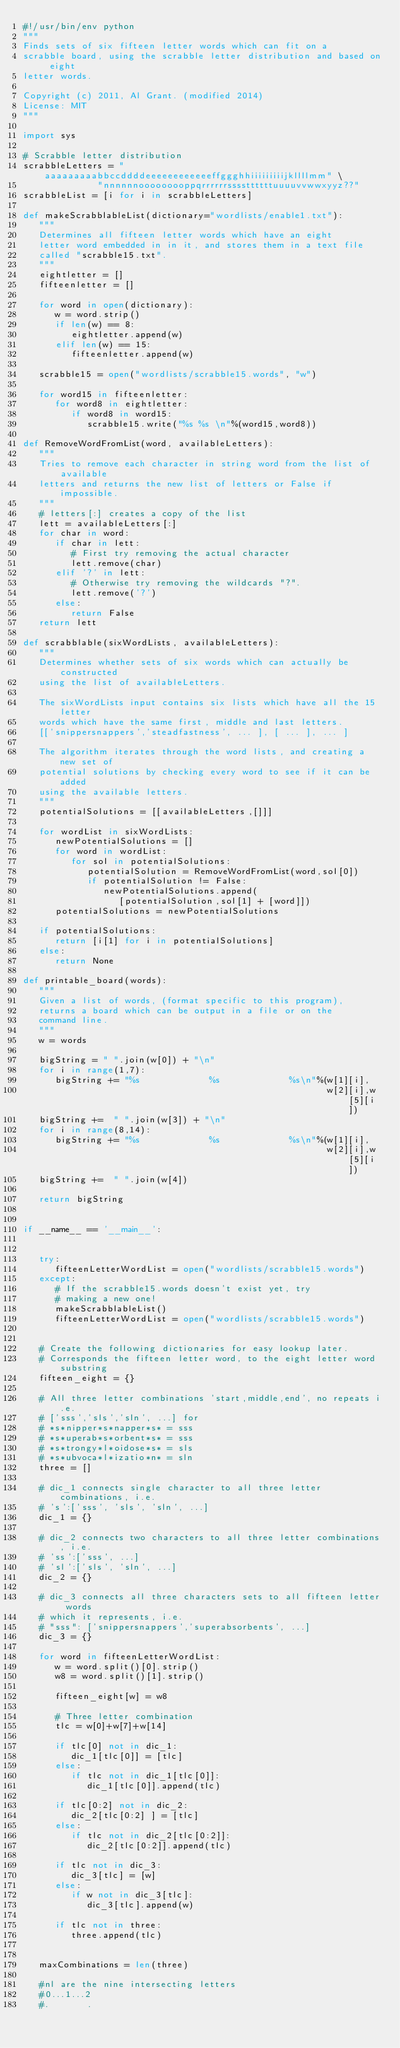Convert code to text. <code><loc_0><loc_0><loc_500><loc_500><_Python_>#!/usr/bin/env python
"""
Finds sets of six fifteen letter words which can fit on a 
scrabble board, using the scrabble letter distribution and based on eight 
letter words.

Copyright (c) 2011, Al Grant. (modified 2014)
License: MIT
"""

import sys

# Scrabble letter distribution
scrabbleLetters = "aaaaaaaaabbccddddeeeeeeeeeeeeffggghhiiiiiiiiijkllllmm" \
              "nnnnnnooooooooppqrrrrrrssssttttttuuuuvvwwxyyz??"
scrabbleList = [i for i in scrabbleLetters]

def makeScrabblableList(dictionary="wordlists/enable1.txt"):
   """
   Determines all fifteen letter words which have an eight
   letter word embedded in in it, and stores them in a text file
   called "scrabble15.txt".
   """
   eightletter = []
   fifteenletter = []   
   
   for word in open(dictionary):
      w = word.strip()
      if len(w) == 8:
         eightletter.append(w)
      elif len(w) == 15:
         fifteenletter.append(w)
  
   scrabble15 = open("wordlists/scrabble15.words", "w")
   
   for word15 in fifteenletter:
      for word8 in eightletter:
         if word8 in word15:
            scrabble15.write("%s %s \n"%(word15,word8))

def RemoveWordFromList(word, availableLetters):
   """
   Tries to remove each character in string word from the list of available 
   letters and returns the new list of letters or False if impossible.
   """
   # letters[:] creates a copy of the list
   lett = availableLetters[:]
   for char in word:
      if char in lett:
         # First try removing the actual character
         lett.remove(char)
      elif '?' in lett:
         # Otherwise try removing the wildcards "?".
         lett.remove('?')
      else:
         return False
   return lett

def scrabblable(sixWordLists, availableLetters):
   """
   Determines whether sets of six words which can actually be constructed 
   using the list of availableLetters.

   The sixWordLists input contains six lists which have all the 15 letter
   words which have the same first, middle and last letters. 
   [['snippersnappers','steadfastness', ... ], [ ... ], ... ]

   The algorithm iterates through the word lists, and creating a new set of
   potential solutions by checking every word to see if it can be added 
   using the available letters.
   """
   potentialSolutions = [[availableLetters,[]]]
   
   for wordList in sixWordLists:
      newPotentialSolutions = []
      for word in wordList:
         for sol in potentialSolutions:
            potentialSolution = RemoveWordFromList(word,sol[0])
            if potentialSolution != False:
               newPotentialSolutions.append(
                  [potentialSolution,sol[1] + [word]])
      potentialSolutions = newPotentialSolutions
   
   if potentialSolutions:
      return [i[1] for i in potentialSolutions]
   else:
      return None
      
def printable_board(words):
   """
   Given a list of words, (format specific to this program), 
   returns a board which can be output in a file or on the
   command line.
   """
   w = words

   bigString = " ".join(w[0]) + "\n"
   for i in range(1,7):
      bigString += "%s             %s             %s\n"%(w[1][i],
                                                         w[2][i],w[5][i])
   bigString +=  " ".join(w[3]) + "\n"
   for i in range(8,14):
      bigString += "%s             %s             %s\n"%(w[1][i],
                                                         w[2][i],w[5][i])
   bigString +=  " ".join(w[4])

   return bigString
            

if __name__ == '__main__':


   try:
      fifteenLetterWordList = open("wordlists/scrabble15.words")
   except:
      # If the scrabble15.words doesn't exist yet, try 
      # making a new one!
      makeScrabblableList()
      fifteenLetterWordList = open("wordlists/scrabble15.words")


   # Create the following dictionaries for easy lookup later.
   # Corresponds the fifteen letter word, to the eight letter word substring
   fifteen_eight = {}

   # All three letter combinations 'start,middle,end', no repeats i.e. 
   # ['sss','sls','sln', ...] for
   # *s*nipper*s*napper*s* = sss
   # *s*uperab*s*orbent*s* = sss
   # *s*trongy*l*oidose*s* = sls
   # *s*ubvoca*l*izatio*n* = sln
   three = []

   # dic_1 connects single character to all three letter combinations, i.e.
   # 's':['sss', 'sls', 'sln', ...]
   dic_1 = {}

   # dic_2 connects two characters to all three letter combinations, i.e.
   # 'ss':['sss', ...]
   # 'sl':['sls', 'sln', ...]
   dic_2 = {}

   # dic_3 connects all three characters sets to all fifteen letter words 
   # which it represents, i.e.
   # "sss": ['snippersnappers','superabsorbents', ...]
   dic_3 = {}

   for word in fifteenLetterWordList:
      w = word.split()[0].strip()
      w8 = word.split()[1].strip()
      
      fifteen_eight[w] = w8
      
      # Three letter combination
      tlc = w[0]+w[7]+w[14]
      
      if tlc[0] not in dic_1:
         dic_1[tlc[0]] = [tlc]
      else:
         if tlc not in dic_1[tlc[0]]:
            dic_1[tlc[0]].append(tlc)
         
      if tlc[0:2] not in dic_2:
         dic_2[tlc[0:2] ] = [tlc]
      else:
         if tlc not in dic_2[tlc[0:2]]:
            dic_2[tlc[0:2]].append(tlc)
         
      if tlc not in dic_3:
         dic_3[tlc] = [w]
      else:
         if w not in dic_3[tlc]:
            dic_3[tlc].append(w)
         
      if tlc not in three:
         three.append(tlc)
   
   
   maxCombinations = len(three)
   
   #nl are the nine intersecting letters
   #0...1...2
   #.       .</code> 